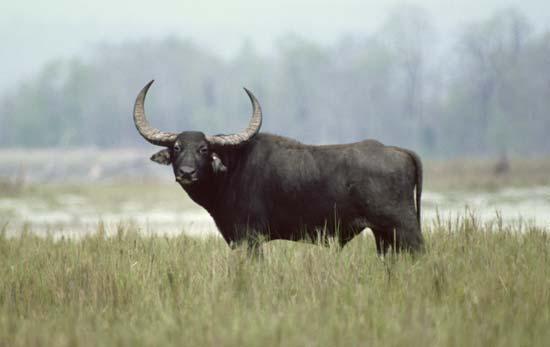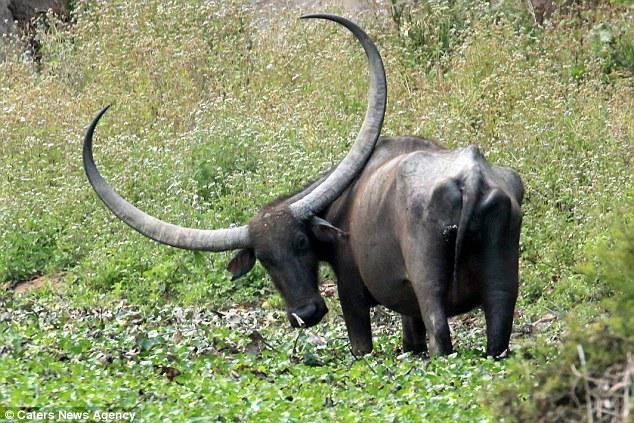The first image is the image on the left, the second image is the image on the right. Considering the images on both sides, is "A water buffalo is walking through water in one image." valid? Answer yes or no. No. The first image is the image on the left, the second image is the image on the right. Examine the images to the left and right. Is the description "A water buffalo happens to be in the water, in one of the images." accurate? Answer yes or no. No. 